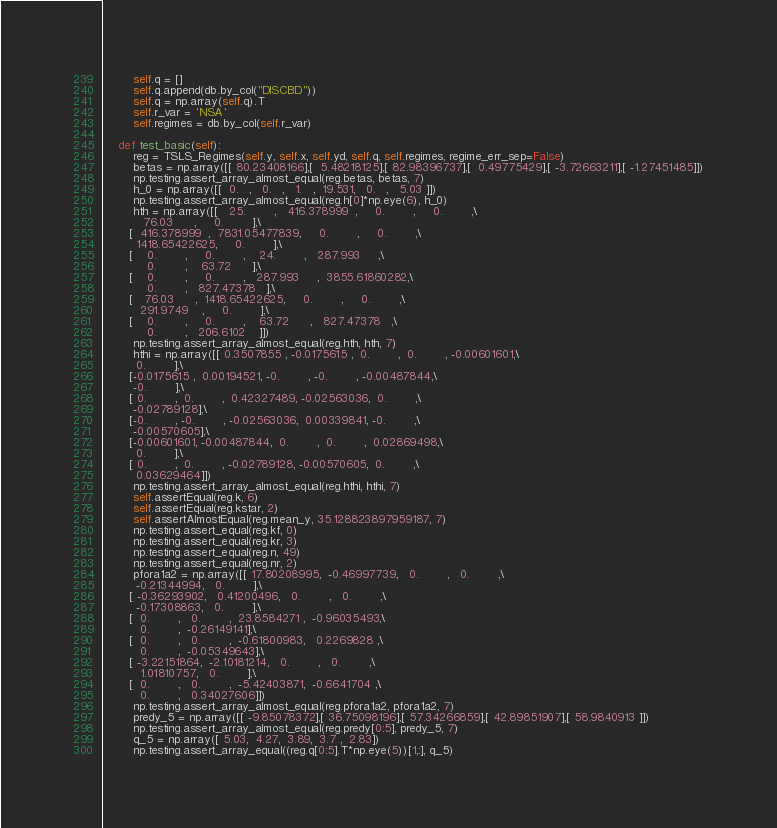<code> <loc_0><loc_0><loc_500><loc_500><_Python_>        self.q = []
        self.q.append(db.by_col("DISCBD"))
        self.q = np.array(self.q).T
        self.r_var = 'NSA'
        self.regimes = db.by_col(self.r_var)

    def test_basic(self):
        reg = TSLS_Regimes(self.y, self.x, self.yd, self.q, self.regimes, regime_err_sep=False)        
        betas = np.array([[ 80.23408166],[  5.48218125],[ 82.98396737],[  0.49775429],[ -3.72663211],[ -1.27451485]])
        np.testing.assert_array_almost_equal(reg.betas, betas, 7)
        h_0 = np.array([[  0.   ,   0.   ,   1.   ,  19.531,   0.   ,   5.03 ]])
        np.testing.assert_array_almost_equal(reg.h[0]*np.eye(6), h_0)
        hth = np.array([[   25.        ,   416.378999  ,     0.        ,     0.        ,\
           76.03      ,     0.        ],\
       [  416.378999  ,  7831.05477839,     0.        ,     0.        ,\
         1418.65422625,     0.        ],\
       [    0.        ,     0.        ,    24.        ,   287.993     ,\
            0.        ,    63.72      ],\
       [    0.        ,     0.        ,   287.993     ,  3855.61860282,\
            0.        ,   827.47378   ],\
       [   76.03      ,  1418.65422625,     0.        ,     0.        ,\
          291.9749    ,     0.        ],\
       [    0.        ,     0.        ,    63.72      ,   827.47378   ,\
            0.        ,   206.6102    ]])
        np.testing.assert_array_almost_equal(reg.hth, hth, 7)
        hthi = np.array([[ 0.3507855 , -0.0175615 ,  0.        ,  0.        , -0.00601601,\
         0.        ],\
       [-0.0175615 ,  0.00194521, -0.        , -0.        , -0.00487844,\
        -0.        ],\
       [ 0.        ,  0.        ,  0.42327489, -0.02563036,  0.        ,\
        -0.02789128],\
       [-0.        , -0.        , -0.02563036,  0.00339841, -0.        ,\
        -0.00570605],\
       [-0.00601601, -0.00487844,  0.        ,  0.        ,  0.02869498,\
         0.        ],\
       [ 0.        ,  0.        , -0.02789128, -0.00570605,  0.        ,\
         0.03629464]])
        np.testing.assert_array_almost_equal(reg.hthi, hthi, 7)
        self.assertEqual(reg.k, 6)
        self.assertEqual(reg.kstar, 2)
        self.assertAlmostEqual(reg.mean_y, 35.128823897959187, 7)
        np.testing.assert_equal(reg.kf, 0)
        np.testing.assert_equal(reg.kr, 3)
        np.testing.assert_equal(reg.n, 49)
        np.testing.assert_equal(reg.nr, 2)
        pfora1a2 = np.array([[ 17.80208995,  -0.46997739,   0.        ,   0.        ,\
         -0.21344994,   0.        ],\
       [ -0.36293902,   0.41200496,   0.        ,   0.        ,\
         -0.17308863,   0.        ],\
       [  0.        ,   0.        ,  23.8584271 ,  -0.96035493,\
          0.        ,  -0.26149141],\
       [  0.        ,   0.        ,  -0.61800983,   0.2269828 ,\
          0.        ,  -0.05349643],\
       [ -3.22151864,  -2.10181214,   0.        ,   0.        ,\
          1.01810757,   0.        ],\
       [  0.        ,   0.        ,  -5.42403871,  -0.6641704 ,\
          0.        ,   0.34027606]]) 
        np.testing.assert_array_almost_equal(reg.pfora1a2, pfora1a2, 7)
        predy_5 = np.array([[ -9.85078372],[ 36.75098196],[ 57.34266859],[ 42.89851907],[ 58.9840913 ]]) 
        np.testing.assert_array_almost_equal(reg.predy[0:5], predy_5, 7)
        q_5 = np.array([ 5.03,  4.27,  3.89,  3.7 ,  2.83])
        np.testing.assert_array_equal((reg.q[0:5].T*np.eye(5))[1,:], q_5)</code> 